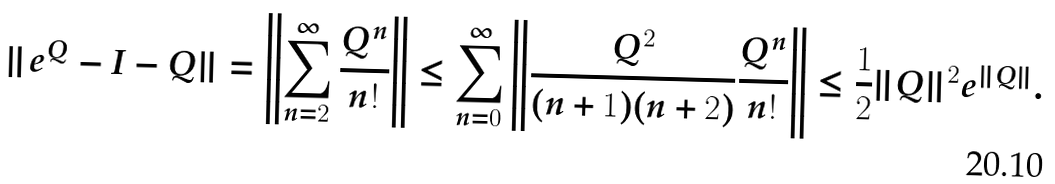<formula> <loc_0><loc_0><loc_500><loc_500>\| e ^ { Q } - I - Q \| & = \left \| \sum _ { n = 2 } ^ { \infty } \frac { Q ^ { n } } { n ! } \right \| \leq \sum _ { n = 0 } ^ { \infty } \left \| \frac { Q ^ { 2 } } { ( n + 1 ) ( n + 2 ) } \frac { Q ^ { n } } { n ! } \right \| \leq \frac { 1 } { 2 } \| Q \| ^ { 2 } e ^ { \| Q \| } .</formula> 